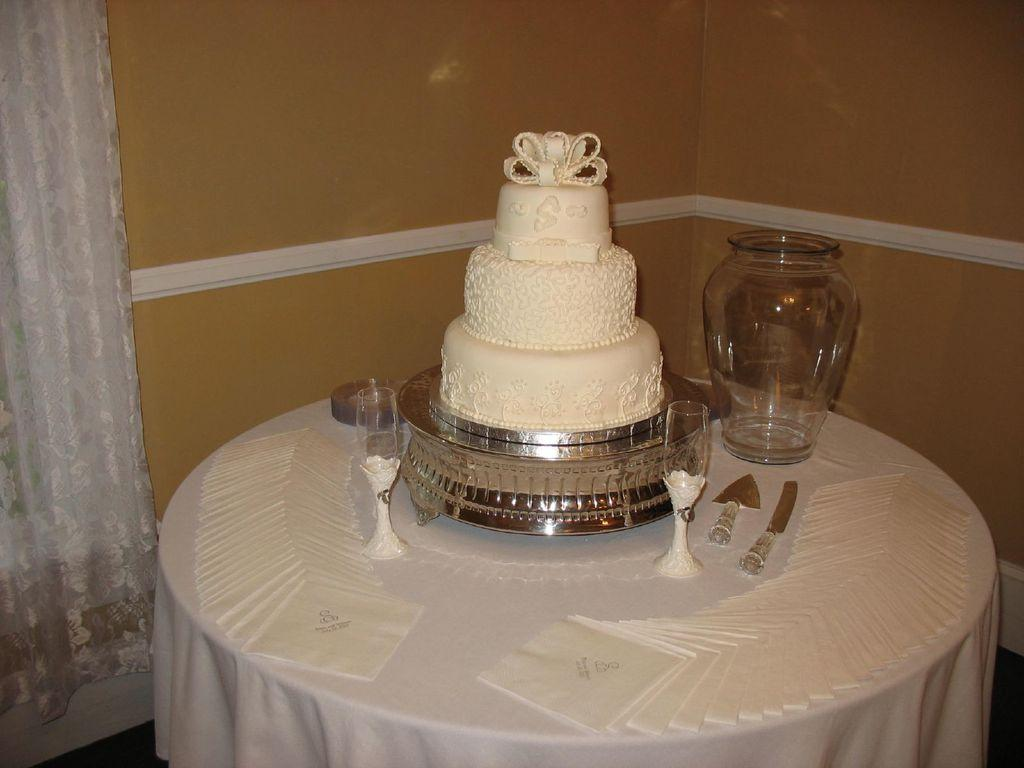What piece of furniture is visible in the image? There is a table in the image. Where is the table located in relation to the wall? The table is in front of a wall. What is covering the wall? The wall is covered with a cloth. What items can be seen on the table? There are glasses, a jar, and a cake on the table. What type of glue is being used to attach the cloth to the wall in the image? There is no glue present in the image, and the cloth is not being attached to the wall. 